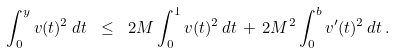Convert formula to latex. <formula><loc_0><loc_0><loc_500><loc_500>\int _ { 0 } ^ { y } v ( t ) ^ { 2 } \, d t \ \leq \ 2 M \int _ { 0 } ^ { 1 } v ( t ) ^ { 2 } \, d t \, + \, 2 M ^ { 2 } \int _ { 0 } ^ { b } v ^ { \prime } ( t ) ^ { 2 } \, d t \, .</formula> 